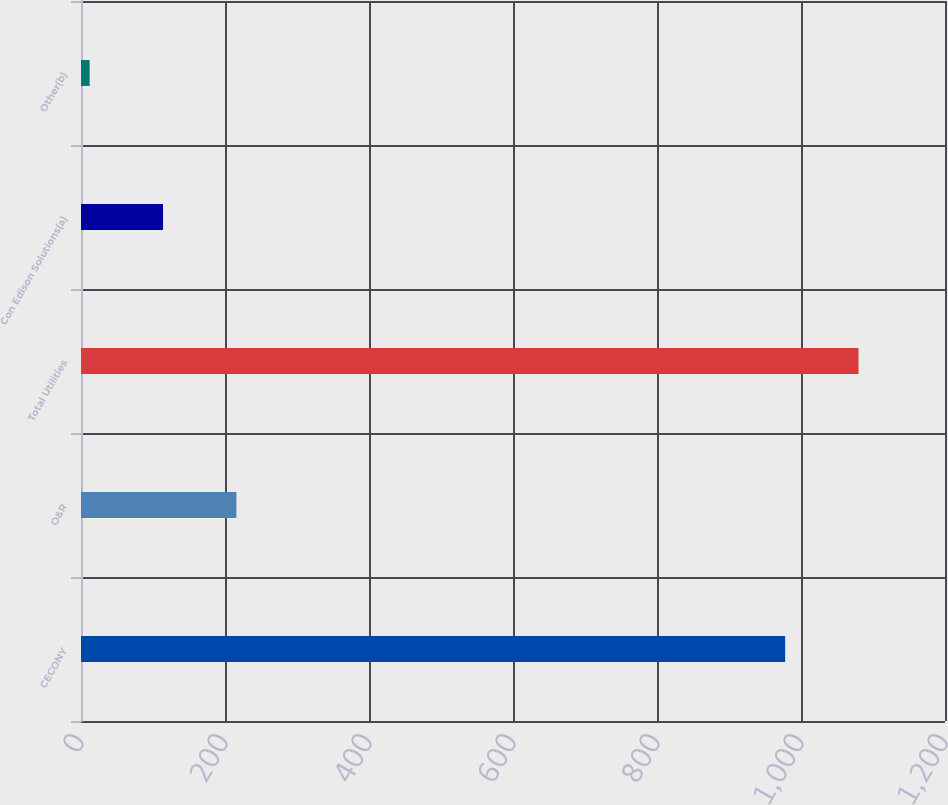<chart> <loc_0><loc_0><loc_500><loc_500><bar_chart><fcel>CECONY<fcel>O&R<fcel>Total Utilities<fcel>Con Edison Solutions(a)<fcel>Other(b)<nl><fcel>978<fcel>215.8<fcel>1079.9<fcel>113.9<fcel>12<nl></chart> 